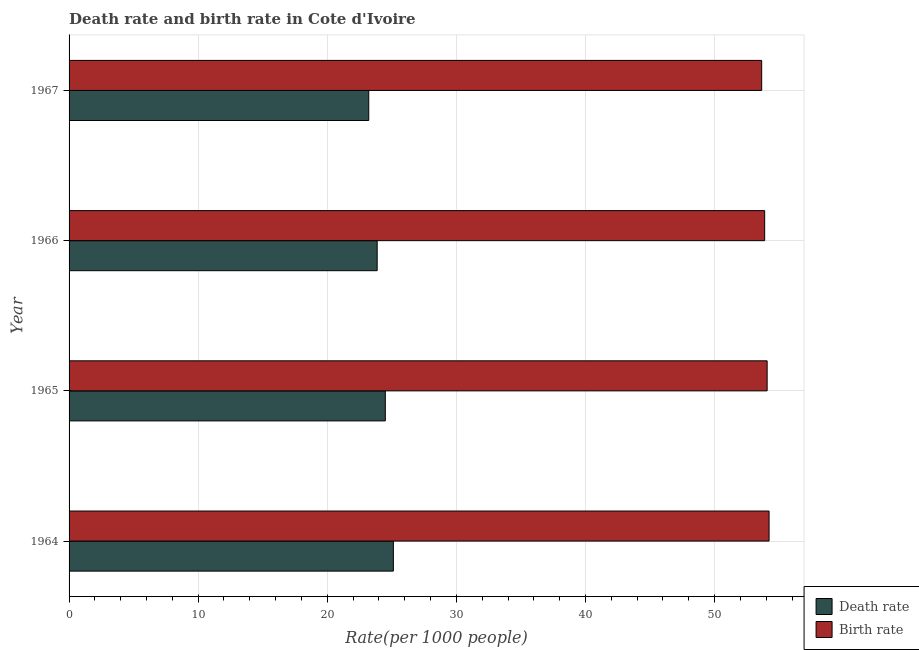How many different coloured bars are there?
Make the answer very short. 2. Are the number of bars on each tick of the Y-axis equal?
Provide a succinct answer. Yes. How many bars are there on the 1st tick from the top?
Give a very brief answer. 2. What is the label of the 1st group of bars from the top?
Make the answer very short. 1967. What is the birth rate in 1967?
Provide a succinct answer. 53.65. Across all years, what is the maximum death rate?
Your answer should be very brief. 25.12. Across all years, what is the minimum birth rate?
Ensure brevity in your answer.  53.65. In which year was the death rate maximum?
Provide a succinct answer. 1964. In which year was the birth rate minimum?
Offer a very short reply. 1967. What is the total birth rate in the graph?
Provide a short and direct response. 215.83. What is the difference between the death rate in 1964 and that in 1967?
Provide a short and direct response. 1.91. What is the difference between the death rate in 1966 and the birth rate in 1967?
Offer a terse response. -29.79. What is the average birth rate per year?
Your response must be concise. 53.96. In the year 1967, what is the difference between the birth rate and death rate?
Provide a short and direct response. 30.44. What is the ratio of the death rate in 1965 to that in 1967?
Your answer should be very brief. 1.05. What is the difference between the highest and the second highest death rate?
Offer a terse response. 0.62. What is the difference between the highest and the lowest birth rate?
Your response must be concise. 0.57. Is the sum of the birth rate in 1964 and 1967 greater than the maximum death rate across all years?
Provide a succinct answer. Yes. What does the 1st bar from the top in 1965 represents?
Provide a short and direct response. Birth rate. What does the 1st bar from the bottom in 1966 represents?
Make the answer very short. Death rate. Are all the bars in the graph horizontal?
Provide a succinct answer. Yes. What is the difference between two consecutive major ticks on the X-axis?
Offer a terse response. 10. Are the values on the major ticks of X-axis written in scientific E-notation?
Make the answer very short. No. Where does the legend appear in the graph?
Keep it short and to the point. Bottom right. What is the title of the graph?
Give a very brief answer. Death rate and birth rate in Cote d'Ivoire. Does "Commercial bank branches" appear as one of the legend labels in the graph?
Offer a terse response. No. What is the label or title of the X-axis?
Your response must be concise. Rate(per 1000 people). What is the label or title of the Y-axis?
Your response must be concise. Year. What is the Rate(per 1000 people) in Death rate in 1964?
Your response must be concise. 25.12. What is the Rate(per 1000 people) in Birth rate in 1964?
Offer a very short reply. 54.22. What is the Rate(per 1000 people) of Death rate in 1965?
Ensure brevity in your answer.  24.5. What is the Rate(per 1000 people) in Birth rate in 1965?
Give a very brief answer. 54.07. What is the Rate(per 1000 people) of Death rate in 1966?
Make the answer very short. 23.86. What is the Rate(per 1000 people) in Birth rate in 1966?
Your response must be concise. 53.88. What is the Rate(per 1000 people) in Death rate in 1967?
Offer a very short reply. 23.21. What is the Rate(per 1000 people) of Birth rate in 1967?
Your answer should be compact. 53.65. Across all years, what is the maximum Rate(per 1000 people) in Death rate?
Provide a short and direct response. 25.12. Across all years, what is the maximum Rate(per 1000 people) of Birth rate?
Your response must be concise. 54.22. Across all years, what is the minimum Rate(per 1000 people) in Death rate?
Give a very brief answer. 23.21. Across all years, what is the minimum Rate(per 1000 people) in Birth rate?
Offer a very short reply. 53.65. What is the total Rate(per 1000 people) in Death rate in the graph?
Provide a short and direct response. 96.69. What is the total Rate(per 1000 people) of Birth rate in the graph?
Your answer should be compact. 215.82. What is the difference between the Rate(per 1000 people) of Death rate in 1964 and that in 1965?
Make the answer very short. 0.62. What is the difference between the Rate(per 1000 people) of Death rate in 1964 and that in 1966?
Your response must be concise. 1.25. What is the difference between the Rate(per 1000 people) in Birth rate in 1964 and that in 1966?
Keep it short and to the point. 0.34. What is the difference between the Rate(per 1000 people) of Death rate in 1964 and that in 1967?
Give a very brief answer. 1.91. What is the difference between the Rate(per 1000 people) in Birth rate in 1964 and that in 1967?
Provide a short and direct response. 0.57. What is the difference between the Rate(per 1000 people) of Death rate in 1965 and that in 1966?
Provide a succinct answer. 0.63. What is the difference between the Rate(per 1000 people) of Birth rate in 1965 and that in 1966?
Your response must be concise. 0.19. What is the difference between the Rate(per 1000 people) of Death rate in 1965 and that in 1967?
Offer a terse response. 1.28. What is the difference between the Rate(per 1000 people) in Birth rate in 1965 and that in 1967?
Give a very brief answer. 0.42. What is the difference between the Rate(per 1000 people) of Death rate in 1966 and that in 1967?
Offer a very short reply. 0.65. What is the difference between the Rate(per 1000 people) of Birth rate in 1966 and that in 1967?
Ensure brevity in your answer.  0.23. What is the difference between the Rate(per 1000 people) in Death rate in 1964 and the Rate(per 1000 people) in Birth rate in 1965?
Provide a succinct answer. -28.95. What is the difference between the Rate(per 1000 people) of Death rate in 1964 and the Rate(per 1000 people) of Birth rate in 1966?
Your answer should be compact. -28.76. What is the difference between the Rate(per 1000 people) in Death rate in 1964 and the Rate(per 1000 people) in Birth rate in 1967?
Give a very brief answer. -28.53. What is the difference between the Rate(per 1000 people) of Death rate in 1965 and the Rate(per 1000 people) of Birth rate in 1966?
Offer a terse response. -29.39. What is the difference between the Rate(per 1000 people) of Death rate in 1965 and the Rate(per 1000 people) of Birth rate in 1967?
Make the answer very short. -29.15. What is the difference between the Rate(per 1000 people) of Death rate in 1966 and the Rate(per 1000 people) of Birth rate in 1967?
Offer a very short reply. -29.79. What is the average Rate(per 1000 people) of Death rate per year?
Provide a short and direct response. 24.17. What is the average Rate(per 1000 people) of Birth rate per year?
Your response must be concise. 53.96. In the year 1964, what is the difference between the Rate(per 1000 people) of Death rate and Rate(per 1000 people) of Birth rate?
Provide a short and direct response. -29.1. In the year 1965, what is the difference between the Rate(per 1000 people) of Death rate and Rate(per 1000 people) of Birth rate?
Your response must be concise. -29.58. In the year 1966, what is the difference between the Rate(per 1000 people) in Death rate and Rate(per 1000 people) in Birth rate?
Make the answer very short. -30.02. In the year 1967, what is the difference between the Rate(per 1000 people) in Death rate and Rate(per 1000 people) in Birth rate?
Your answer should be compact. -30.44. What is the ratio of the Rate(per 1000 people) of Death rate in 1964 to that in 1965?
Keep it short and to the point. 1.03. What is the ratio of the Rate(per 1000 people) of Birth rate in 1964 to that in 1965?
Your answer should be very brief. 1. What is the ratio of the Rate(per 1000 people) in Death rate in 1964 to that in 1966?
Your answer should be very brief. 1.05. What is the ratio of the Rate(per 1000 people) in Birth rate in 1964 to that in 1966?
Your answer should be very brief. 1.01. What is the ratio of the Rate(per 1000 people) in Death rate in 1964 to that in 1967?
Make the answer very short. 1.08. What is the ratio of the Rate(per 1000 people) in Birth rate in 1964 to that in 1967?
Offer a very short reply. 1.01. What is the ratio of the Rate(per 1000 people) in Death rate in 1965 to that in 1966?
Your answer should be compact. 1.03. What is the ratio of the Rate(per 1000 people) of Birth rate in 1965 to that in 1966?
Your answer should be very brief. 1. What is the ratio of the Rate(per 1000 people) in Death rate in 1965 to that in 1967?
Your response must be concise. 1.06. What is the ratio of the Rate(per 1000 people) of Birth rate in 1965 to that in 1967?
Your answer should be compact. 1.01. What is the ratio of the Rate(per 1000 people) of Death rate in 1966 to that in 1967?
Offer a terse response. 1.03. What is the ratio of the Rate(per 1000 people) in Birth rate in 1966 to that in 1967?
Ensure brevity in your answer.  1. What is the difference between the highest and the second highest Rate(per 1000 people) of Death rate?
Offer a very short reply. 0.62. What is the difference between the highest and the second highest Rate(per 1000 people) of Birth rate?
Your response must be concise. 0.15. What is the difference between the highest and the lowest Rate(per 1000 people) in Death rate?
Your answer should be compact. 1.91. What is the difference between the highest and the lowest Rate(per 1000 people) in Birth rate?
Make the answer very short. 0.57. 